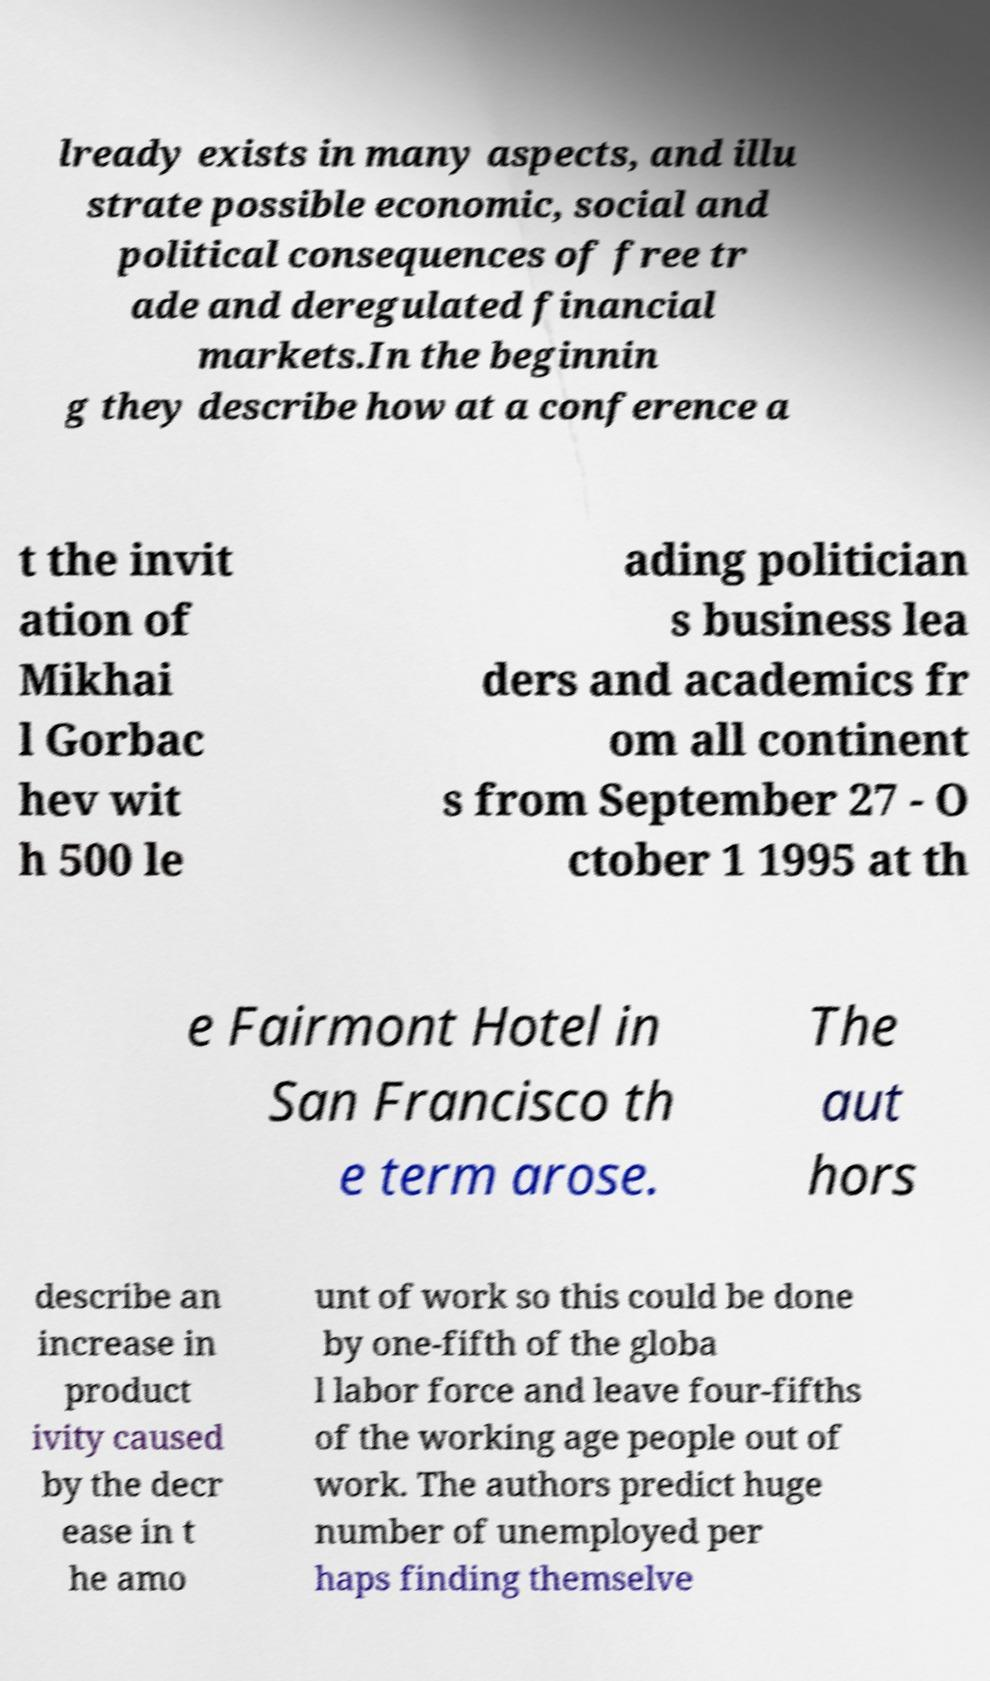Could you extract and type out the text from this image? lready exists in many aspects, and illu strate possible economic, social and political consequences of free tr ade and deregulated financial markets.In the beginnin g they describe how at a conference a t the invit ation of Mikhai l Gorbac hev wit h 500 le ading politician s business lea ders and academics fr om all continent s from September 27 - O ctober 1 1995 at th e Fairmont Hotel in San Francisco th e term arose. The aut hors describe an increase in product ivity caused by the decr ease in t he amo unt of work so this could be done by one-fifth of the globa l labor force and leave four-fifths of the working age people out of work. The authors predict huge number of unemployed per haps finding themselve 